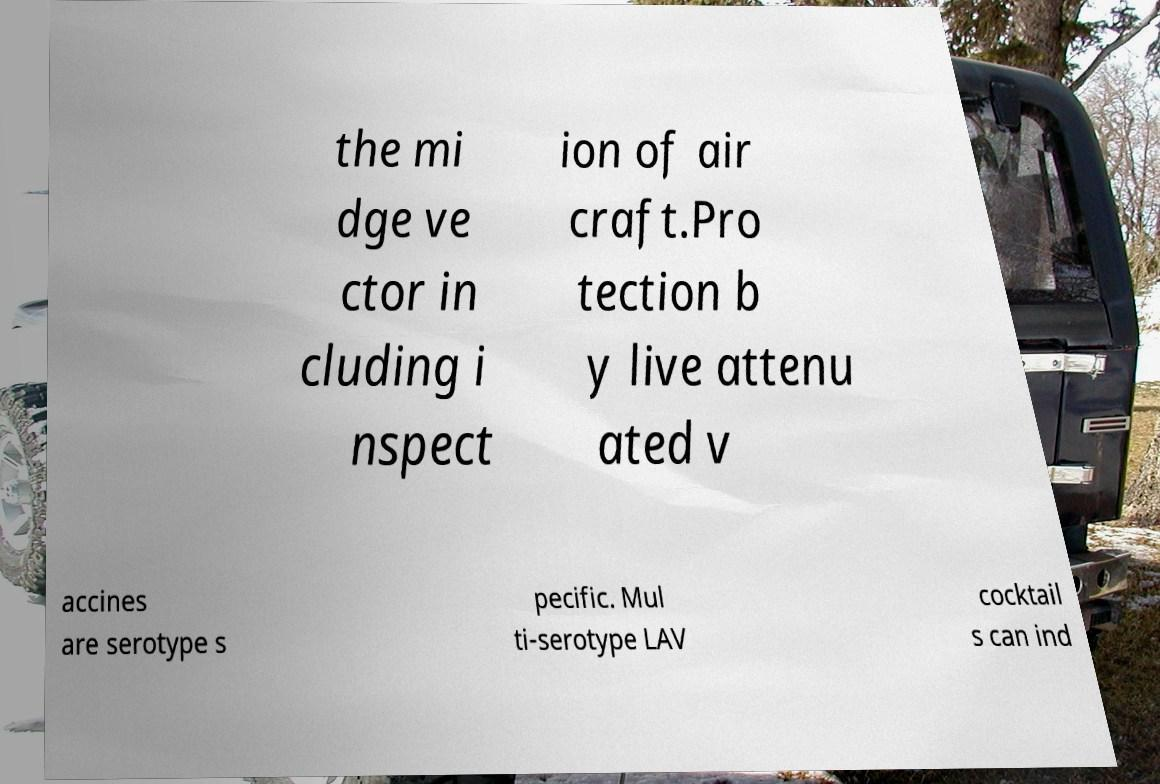Could you extract and type out the text from this image? the mi dge ve ctor in cluding i nspect ion of air craft.Pro tection b y live attenu ated v accines are serotype s pecific. Mul ti-serotype LAV cocktail s can ind 